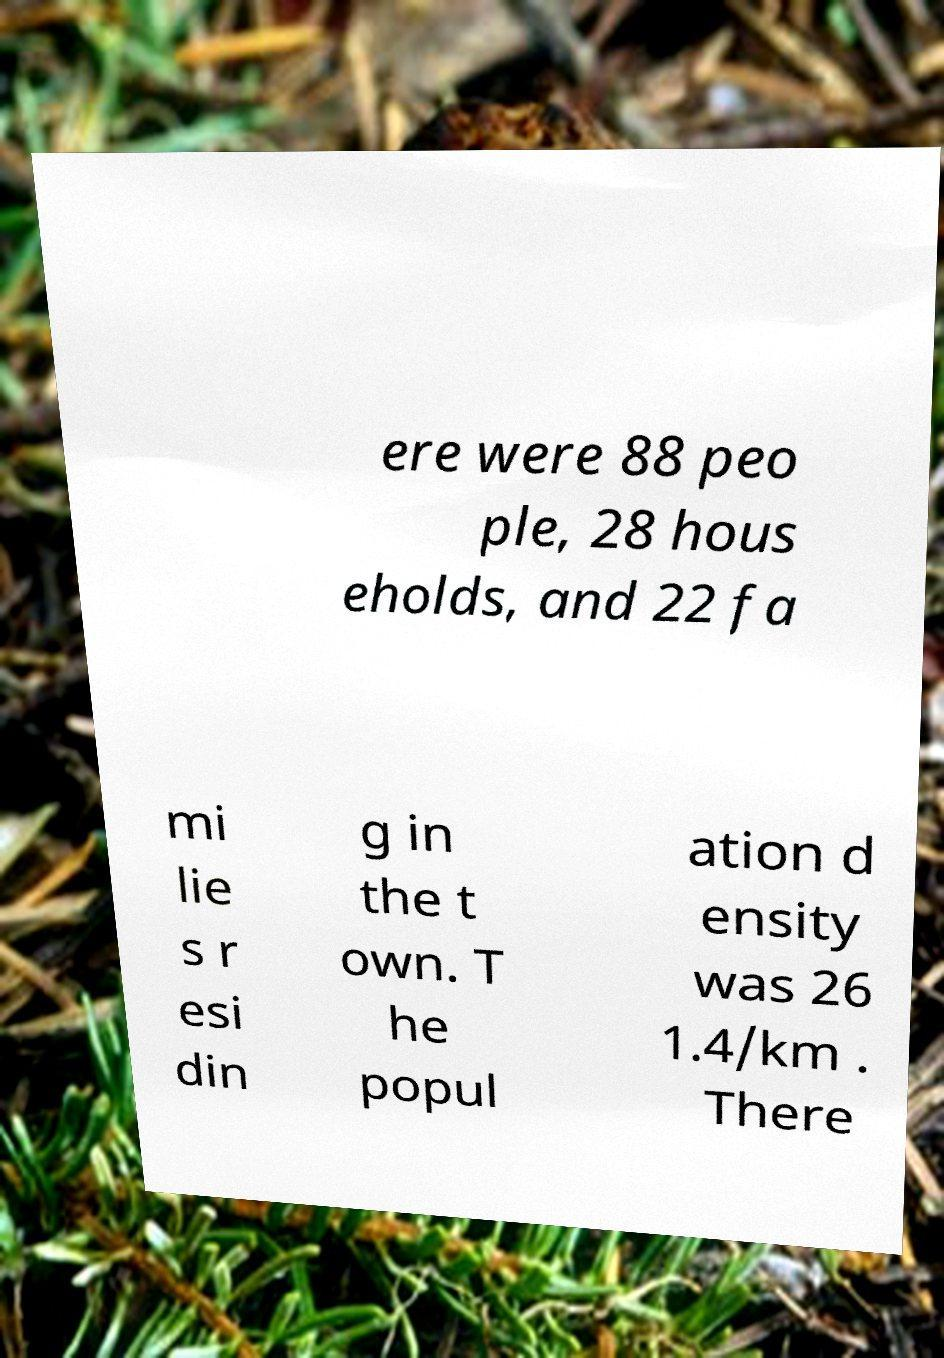Please read and relay the text visible in this image. What does it say? ere were 88 peo ple, 28 hous eholds, and 22 fa mi lie s r esi din g in the t own. T he popul ation d ensity was 26 1.4/km . There 